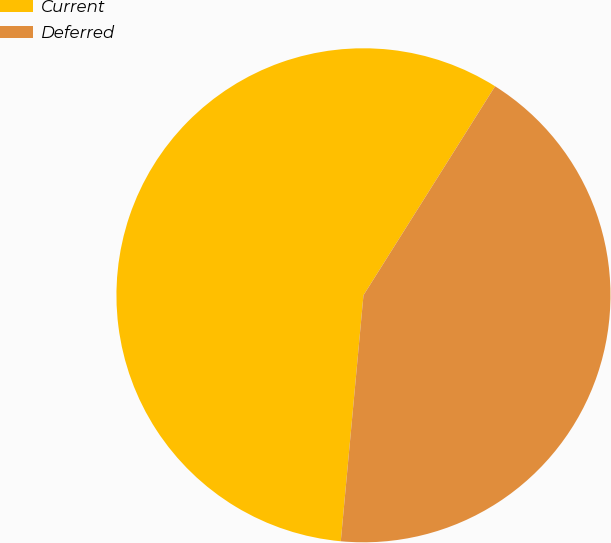<chart> <loc_0><loc_0><loc_500><loc_500><pie_chart><fcel>Current<fcel>Deferred<nl><fcel>57.48%<fcel>42.52%<nl></chart> 